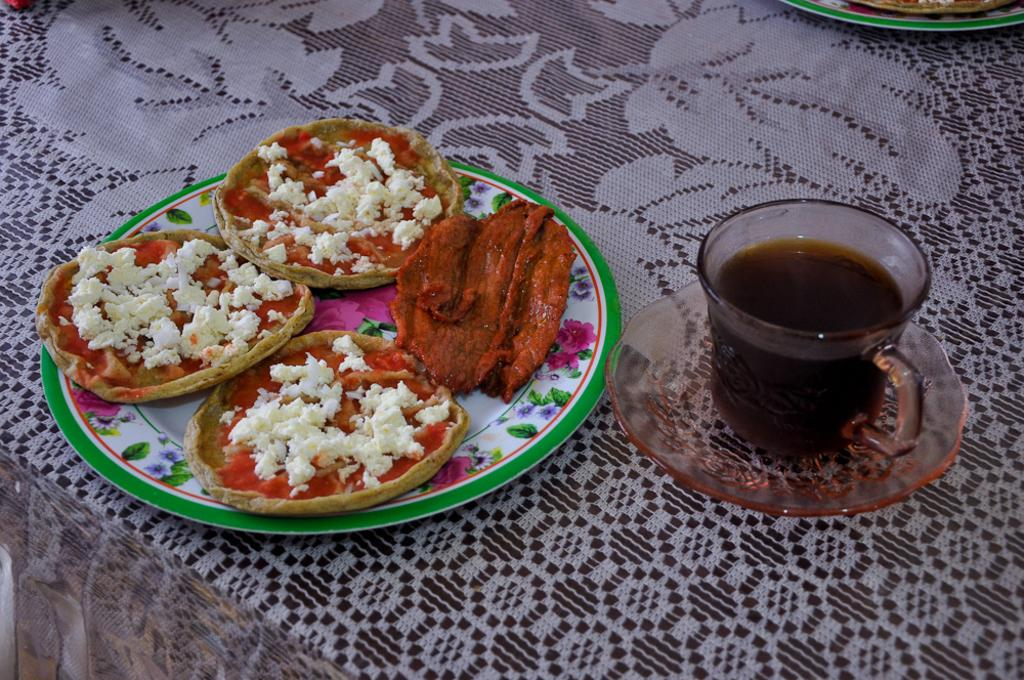What piece of furniture is present in the image? There is a table in the image. What is covering the table? There is a cloth on the table. What is on the table that suggests it is a meal setting? There is a plate full of food and a cup with a drink in it on the table. What additional item is present on the table? There is a saucer on the table. Where is the lamp located in the image? There is no lamp present in the image. What type of cave can be seen in the image? There is no cave present in the image. 